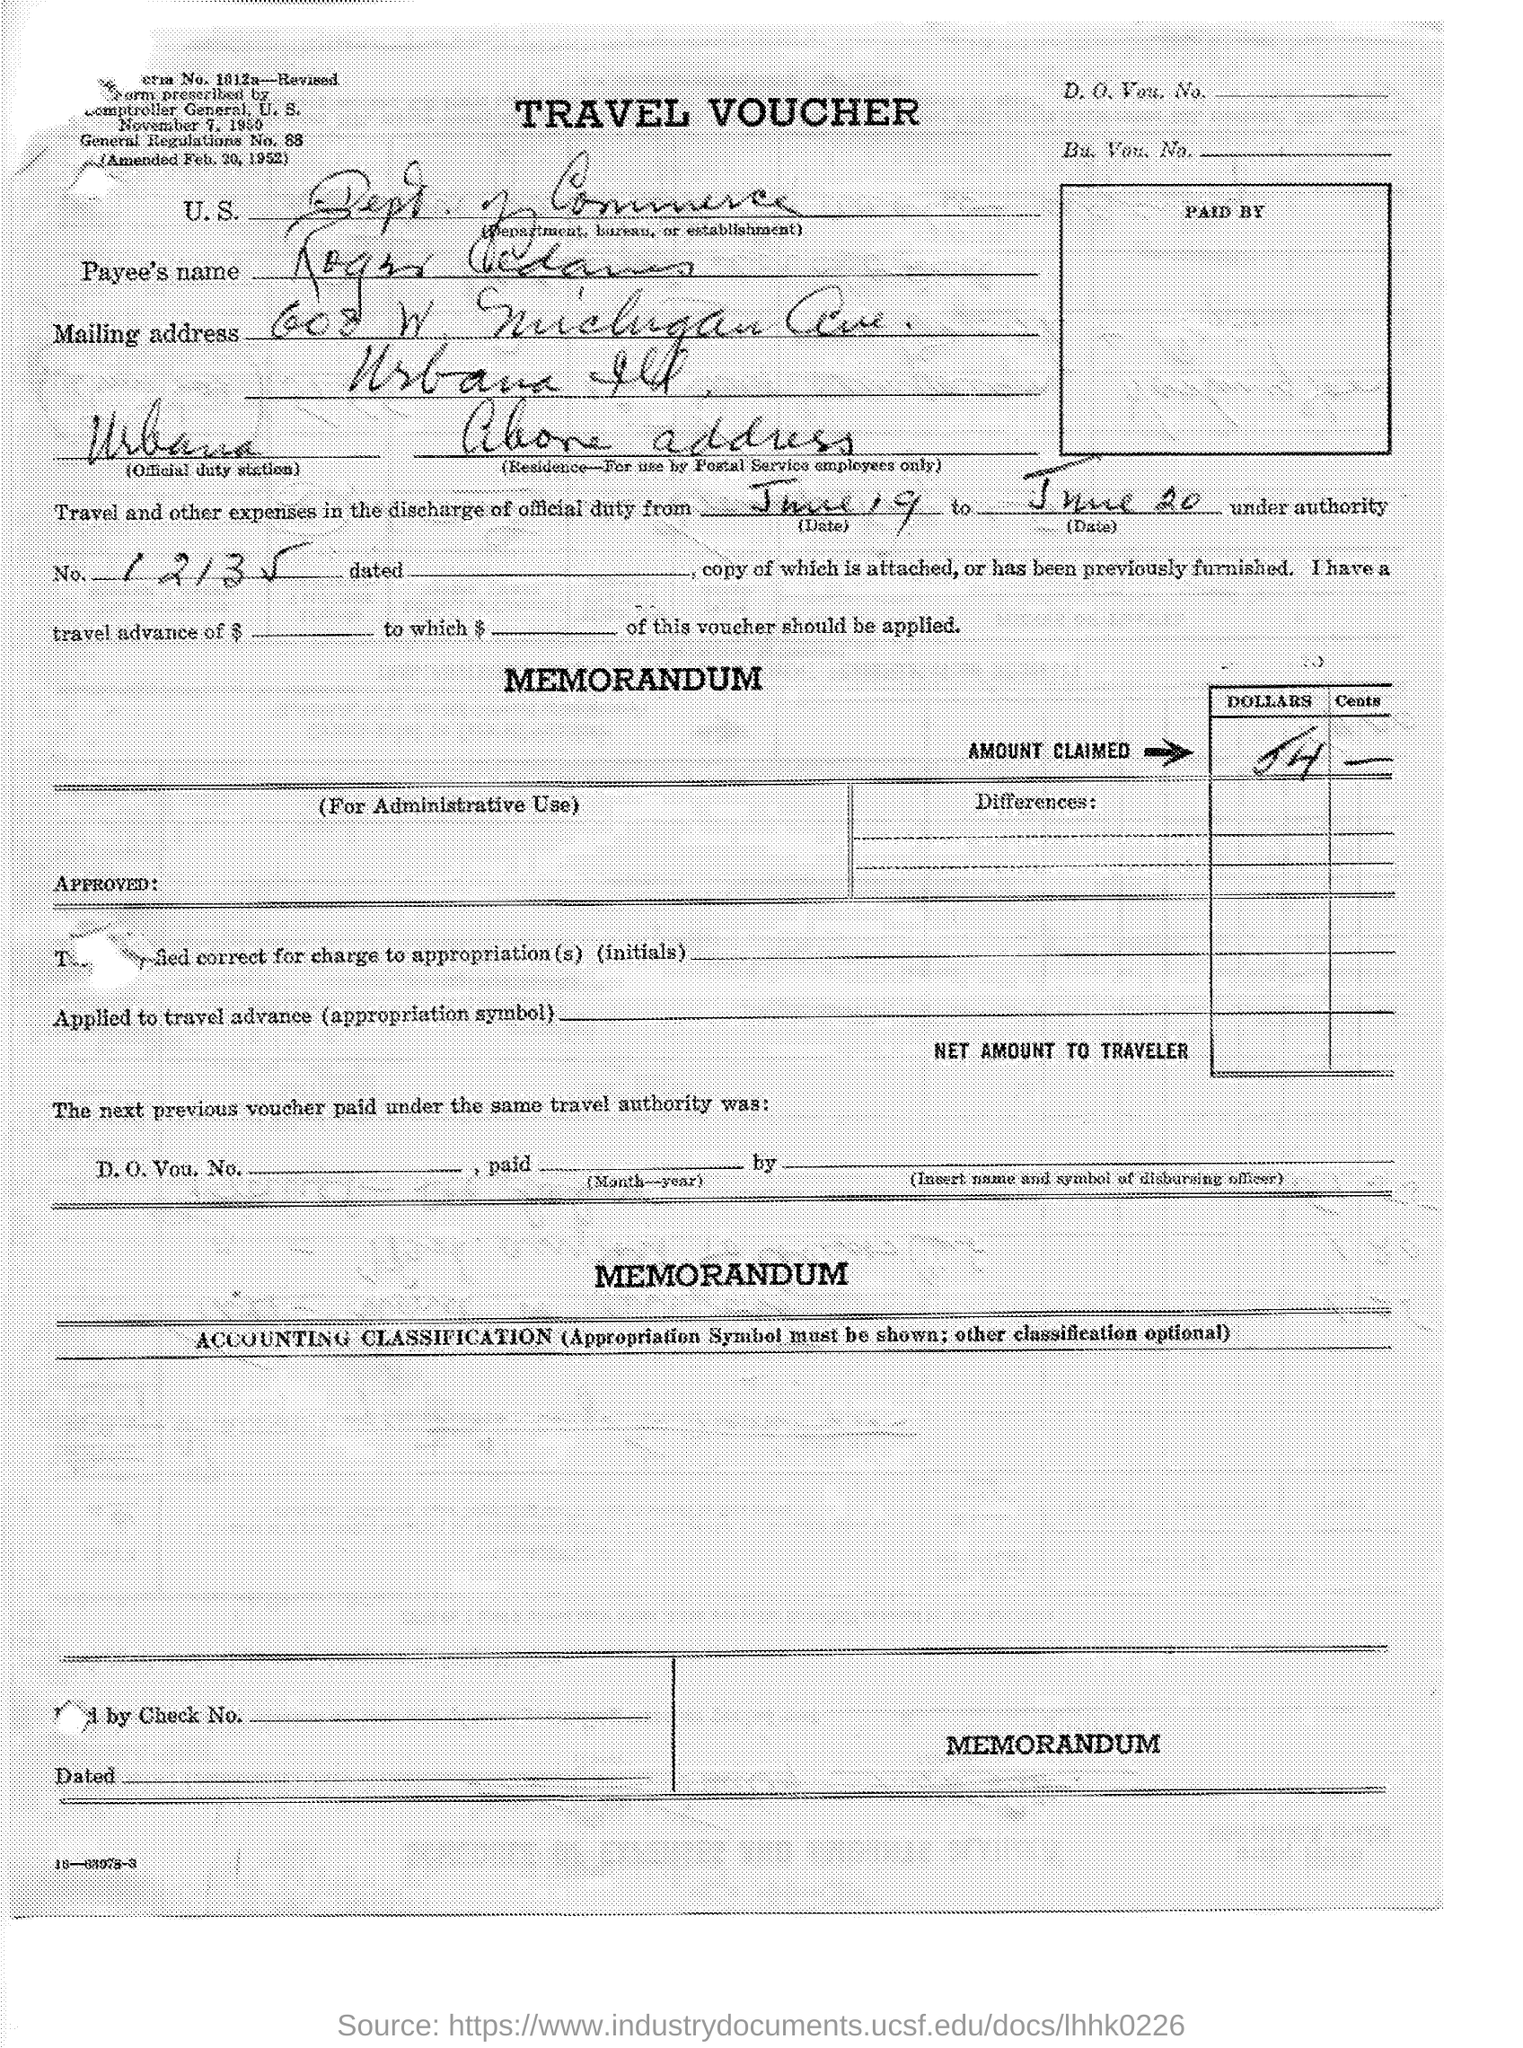What type of documentation is this?
Your response must be concise. TRAVEL VOUCHER. 